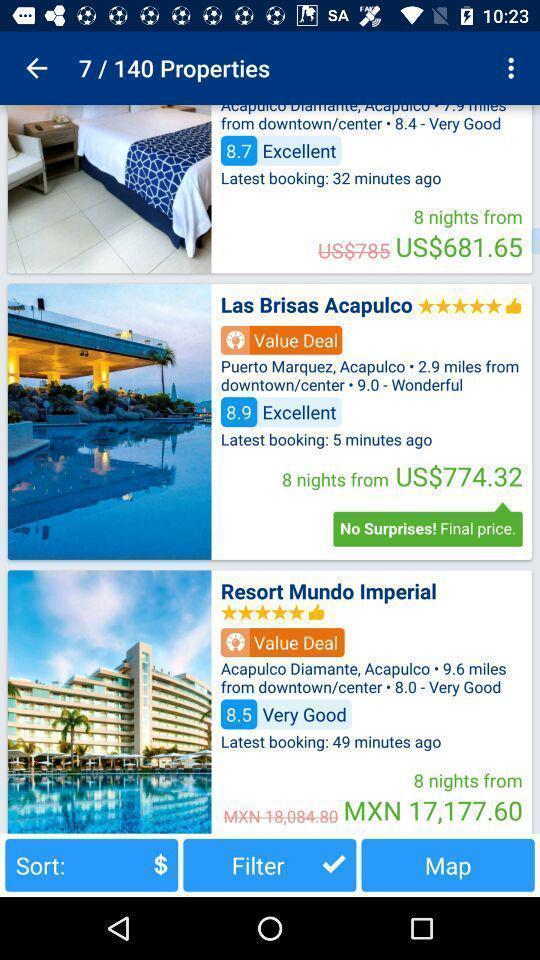Provide a detailed account of this screenshot. Screen page displaying various hotels in booking application. 